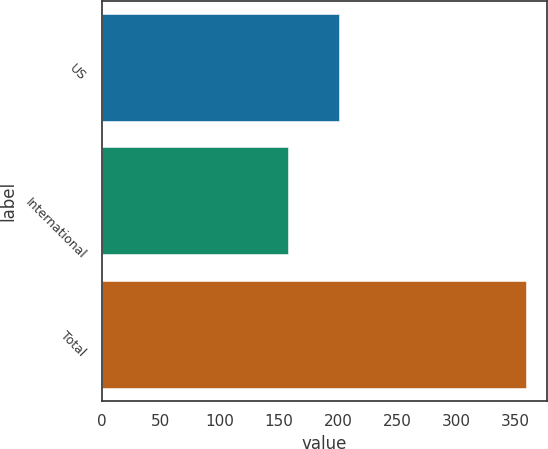<chart> <loc_0><loc_0><loc_500><loc_500><bar_chart><fcel>US<fcel>International<fcel>Total<nl><fcel>201<fcel>158<fcel>359<nl></chart> 